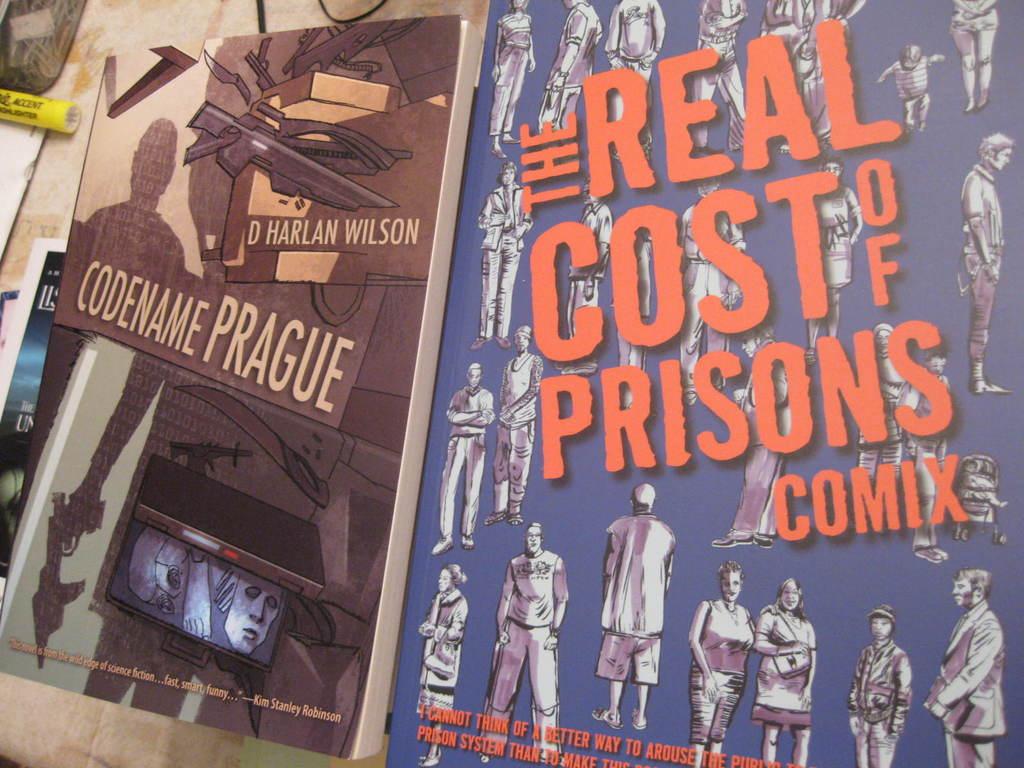What is the codename on the left?
Offer a very short reply. Prague. 